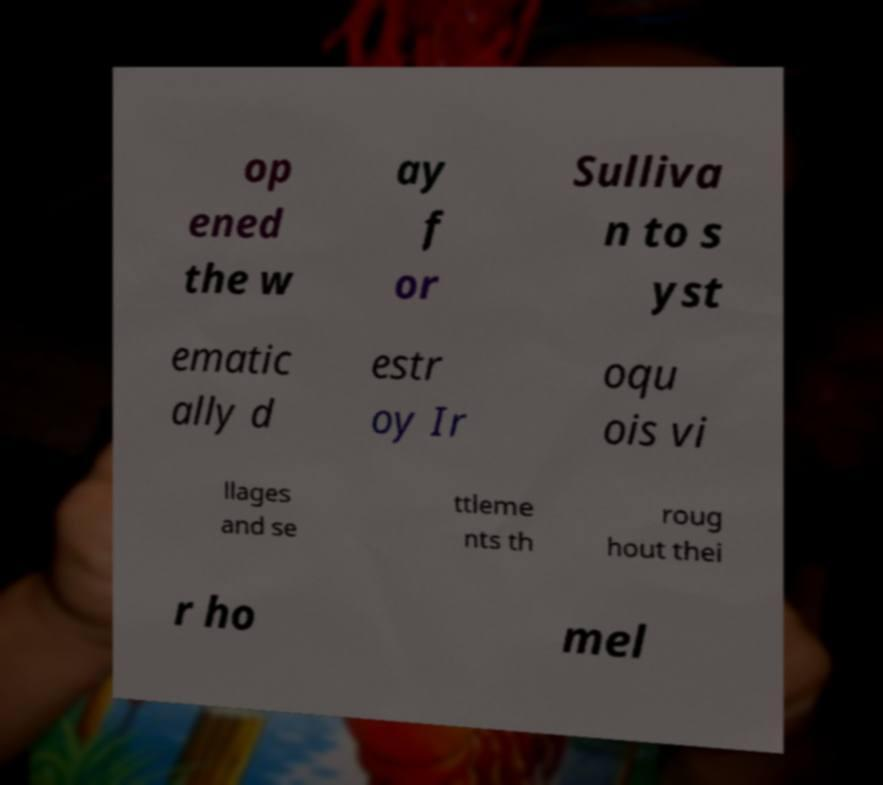I need the written content from this picture converted into text. Can you do that? op ened the w ay f or Sulliva n to s yst ematic ally d estr oy Ir oqu ois vi llages and se ttleme nts th roug hout thei r ho mel 